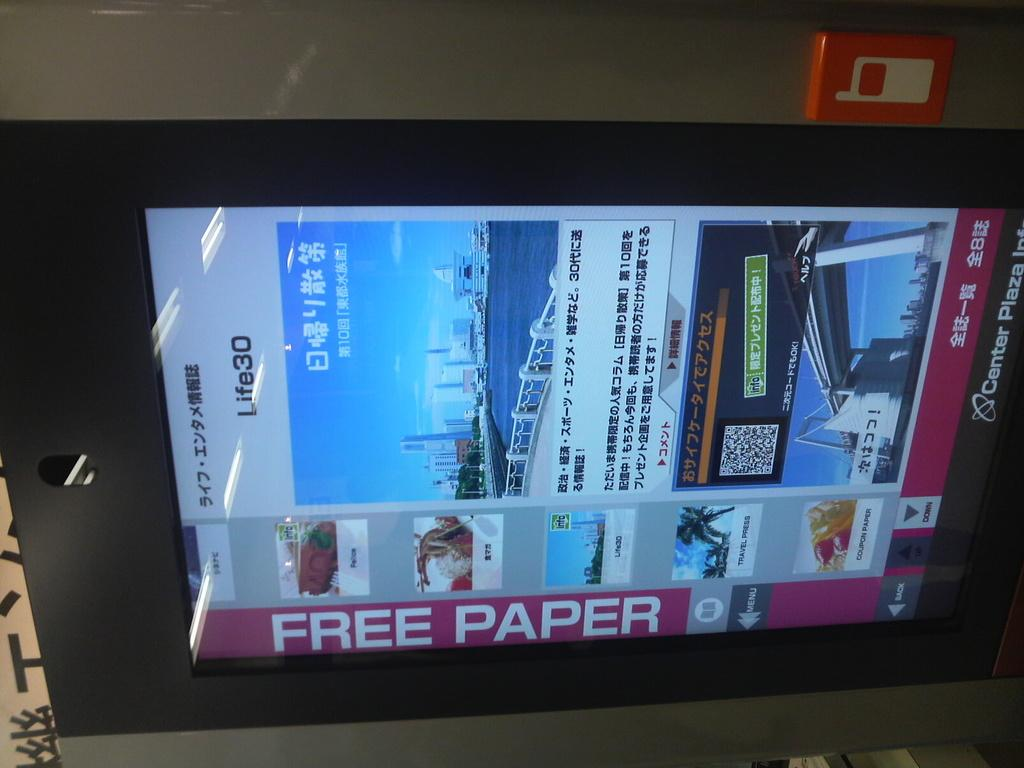<image>
Summarize the visual content of the image. the words free paper that are on a screen 